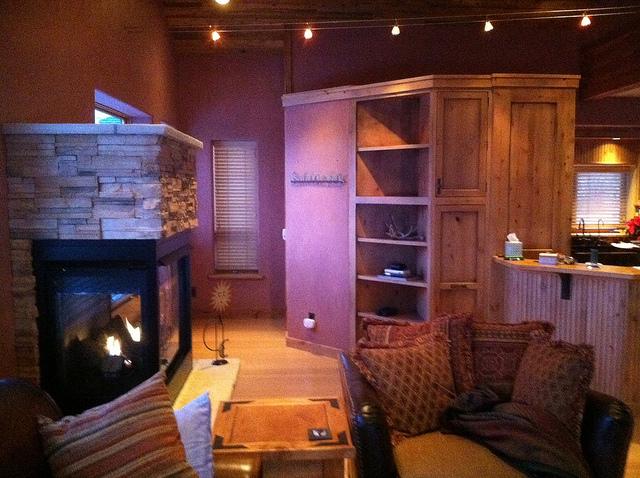Is this home located in Florida?
Quick response, please. No. Is that a real fireplace or just propane?
Be succinct. Propane. Is this room cozy?
Quick response, please. Yes. 